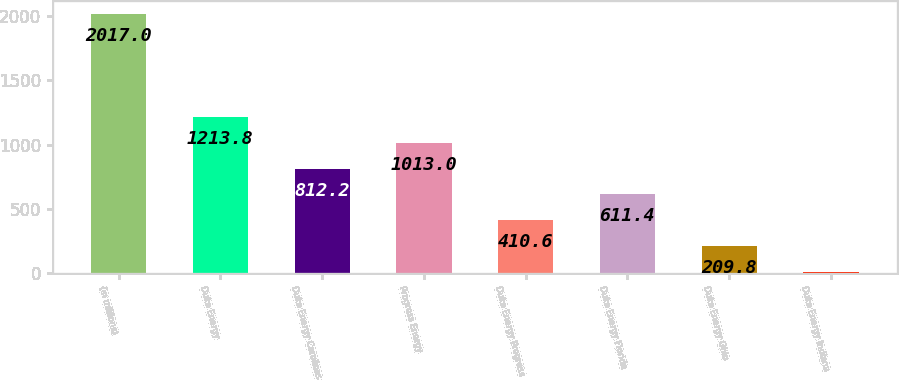Convert chart to OTSL. <chart><loc_0><loc_0><loc_500><loc_500><bar_chart><fcel>(in millions)<fcel>Duke Energy<fcel>Duke Energy Carolinas<fcel>Progress Energy<fcel>Duke Energy Progress<fcel>Duke Energy Florida<fcel>Duke Energy Ohio<fcel>Duke Energy Indiana<nl><fcel>2017<fcel>1213.8<fcel>812.2<fcel>1013<fcel>410.6<fcel>611.4<fcel>209.8<fcel>9<nl></chart> 